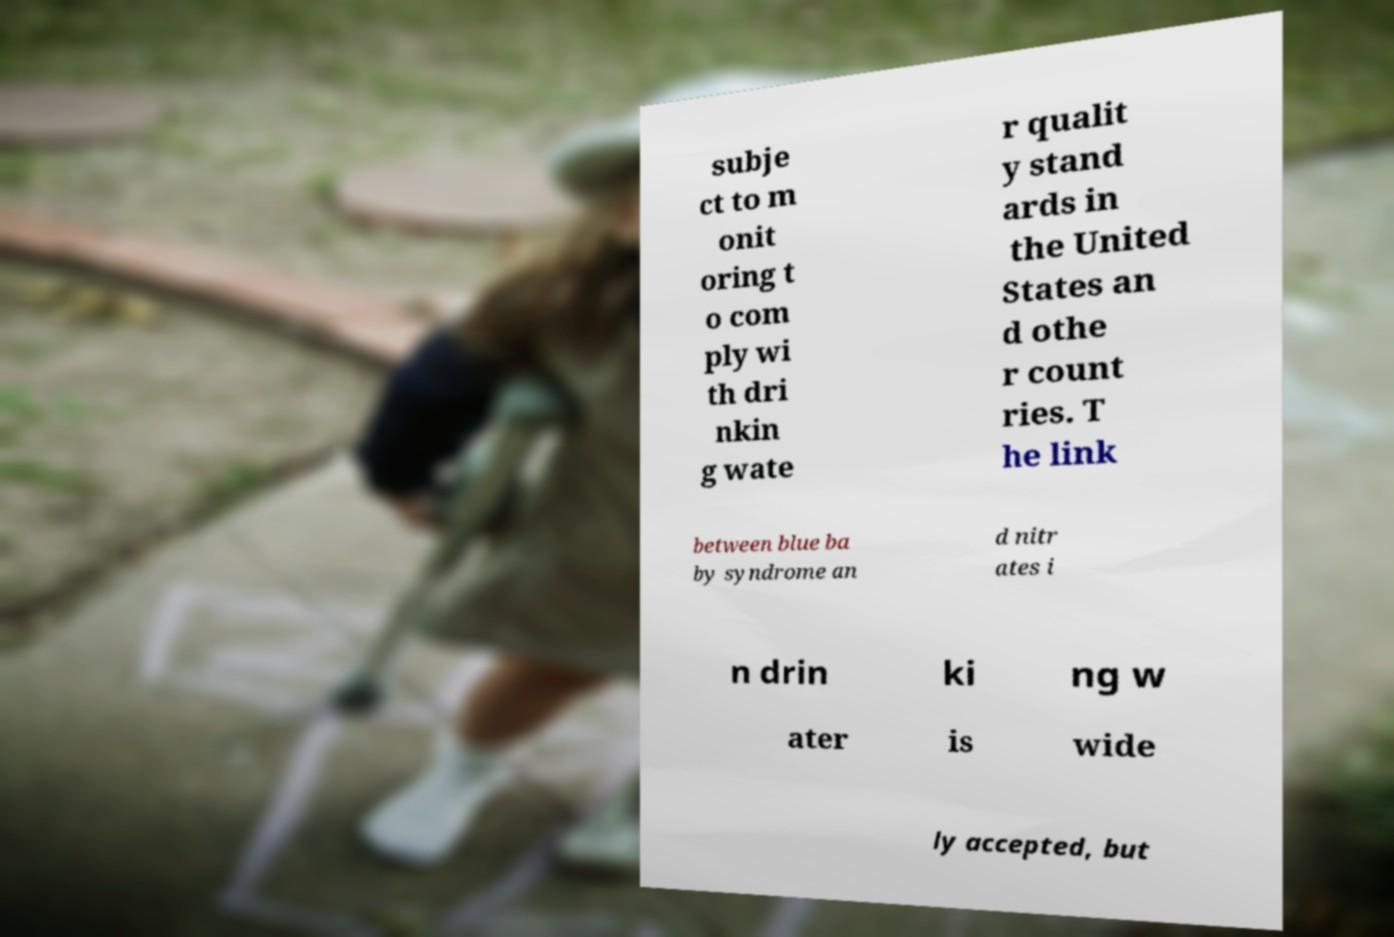Can you read and provide the text displayed in the image?This photo seems to have some interesting text. Can you extract and type it out for me? subje ct to m onit oring t o com ply wi th dri nkin g wate r qualit y stand ards in the United States an d othe r count ries. T he link between blue ba by syndrome an d nitr ates i n drin ki ng w ater is wide ly accepted, but 